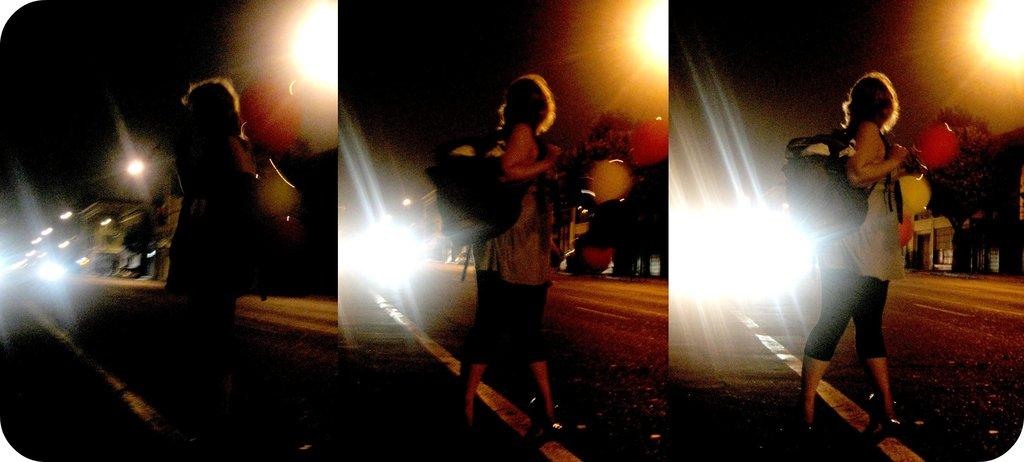What is the composition of the image? The image is a collage of three similar pictures. Can you describe the person in the image? There is a person standing in the image, and they are wearing a bag. What type of structures can be seen in the image? Buildings are visible in the image. What are the street poles used for in the image? Street poles are present beside the road in the image, likely for holding signs or streetlights. What type of pig can be seen running through the airport in the image? There is no pig or airport present in the image; it features a collage of three similar pictures with a person standing, wearing a bag, and surrounded by buildings and street poles. 